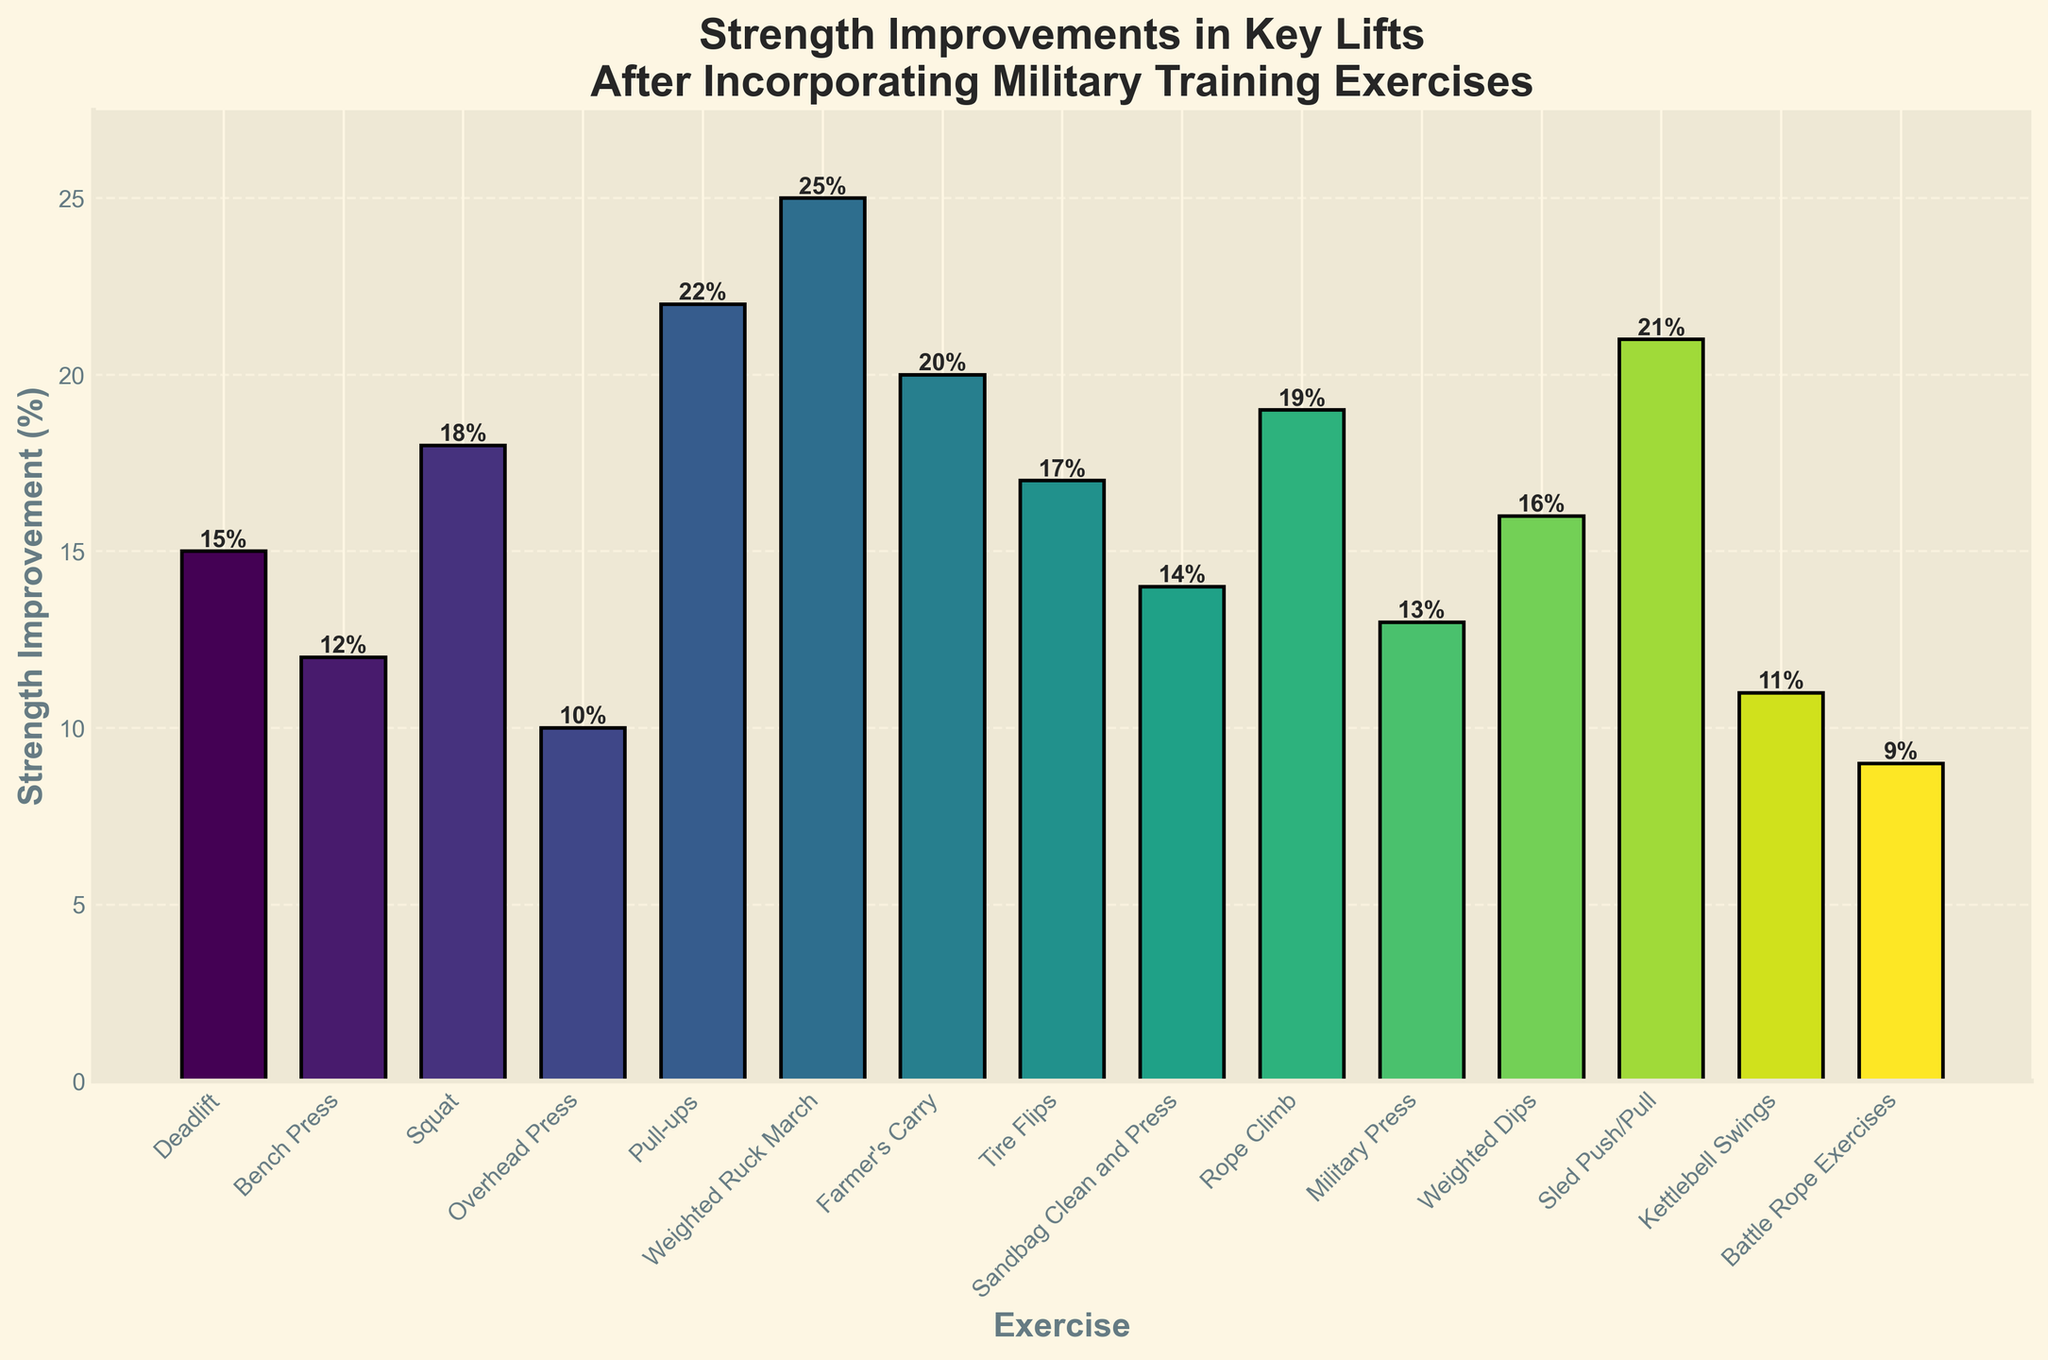What is the strength improvement percentage for the exercise with the highest increase? The highest bar in the chart represents the Weighted Ruck March, with a strength improvement of 25%, as indicated by the height of the bar and the number at its top.
Answer: 25% Which exercise experienced the lowest strength improvement? The Battle Rope Exercises show the lowest bar, indicating a 9% improvement, as can be seen both by the bar height and the labeled value.
Answer: Battle Rope Exercises What's the overall range of strength improvement percentages across all exercises? The range is calculated by subtracting the lowest percentage (9% for Battle Rope Exercises) from the highest percentage (25% for Weighted Ruck March). Thus, 25% - 9% = 16%.
Answer: 16% What's the average strength improvement percentage for Deadlift, Squat, and Sled Push/Pull? The respective improvements are 15%, 18%, and 21%. The average is calculated by adding these values and dividing by 3: (15 + 18 + 21) / 3 = 54 / 3 = 18.
Answer: 18% What is the strength improvement percentage difference between Pull-ups and Kettlebell Swings? Pull-ups have a 22% improvement, and Kettlebell Swings have 11%. The difference is 22% - 11% = 11%.
Answer: 11% How many exercises have a strength improvement percentage greater than 15%? By examining the chart, we can count the bars with values greater than 15%: Squat, Pull-ups, Weighted Ruck March, Farmer's Carry, Tire Flips, Rope Climb, Weighted Dips, and Sled Push/Pull. This totals 8 exercises.
Answer: 8 Which exercise categories demonstrate exactly 14% strength improvement? The chart shows that the Sandbag Clean and Press has a strength improvement of 14%, as indicated by its bar height and label.
Answer: Sandbag Clean and Press What is the median value of the strength improvements? Listing the percentages in order (9%, 10%, 11%, 12%, 13%, 14%, 15%, 16%, 17%, 18%, 19%, 20%, 21%, 22%, 25%), the median, or middle value, when sorted is the 16% for Farmer's Carry since there are 15 data points.
Answer: 16% Which two exercises have a strength improvement percentage difference of 7%? Deadlifting (15%) and Rope Climb (19%) have a difference of 4%. Farmer's Carry (20%) and Bench Press (12%) have a difference of 8%. Tire Flips (17%) and Military Press (13%) have a difference of 4%. So there appear to be no pairs with exactly 7%.
Answer: None 